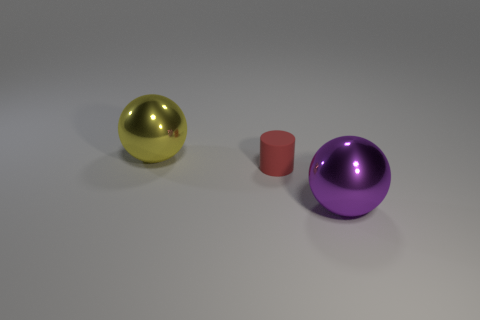Subtract all cylinders. How many objects are left? 2 Subtract 1 cylinders. How many cylinders are left? 0 Subtract all purple spheres. Subtract all cyan cubes. How many spheres are left? 1 Subtract all purple cylinders. How many purple spheres are left? 1 Subtract all shiny objects. Subtract all big blue metallic objects. How many objects are left? 1 Add 1 big purple metallic spheres. How many big purple metallic spheres are left? 2 Add 3 yellow objects. How many yellow objects exist? 4 Add 3 gray rubber cubes. How many objects exist? 6 Subtract all yellow balls. How many balls are left? 1 Subtract 0 gray cylinders. How many objects are left? 3 